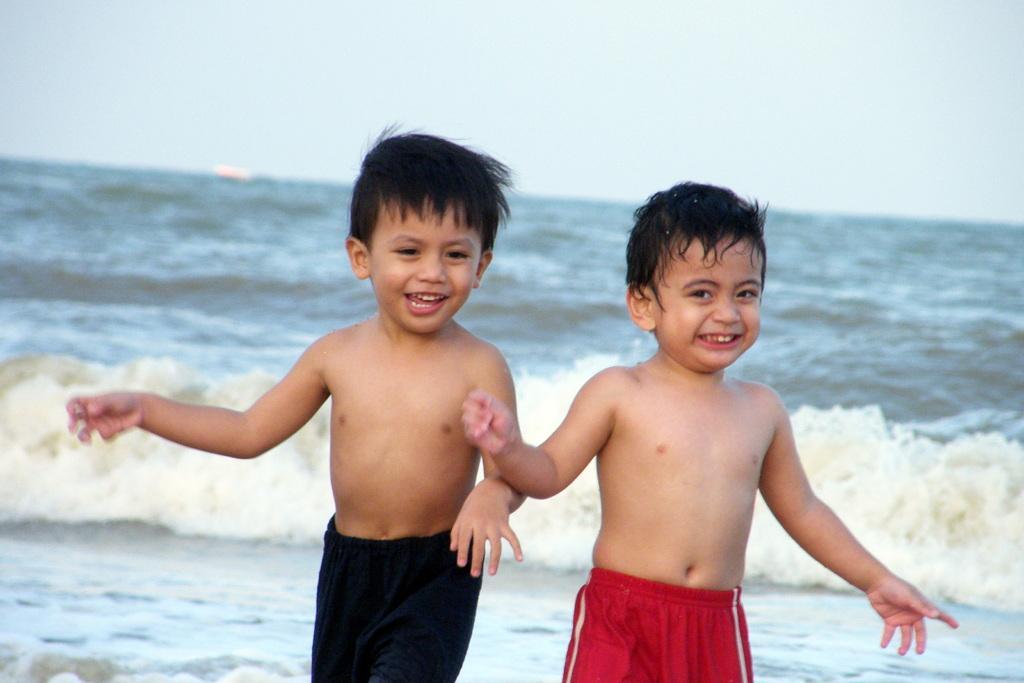Describe this image in one or two sentences. In this image I can see two people with red and black color dresses. In the background I can see the water and the sky. 